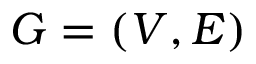<formula> <loc_0><loc_0><loc_500><loc_500>G = ( V , E )</formula> 